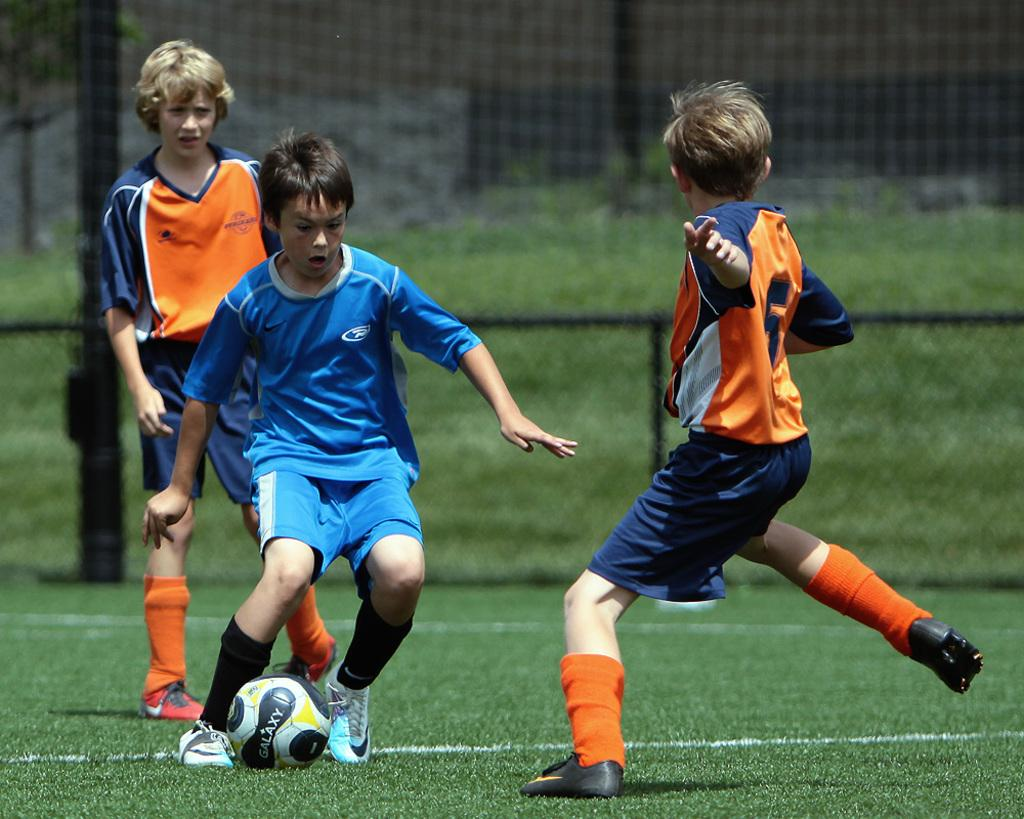What are the children in the image doing? The children are running on the ground in the image. What type of activity is being depicted in the image? There is a sportsnet in the image, suggesting a sports-related activity. What can be seen surrounding the area where the children are running? There are fences and bushes in the image. What object is on the ground that might be related to the activity? There is a ball on the ground in the image. Can you see any paste being used by the children in the image? There is no paste present in the image; it features children running and a sports-related activity. Are there any horses visible in the image? There are no horses present in the image. 